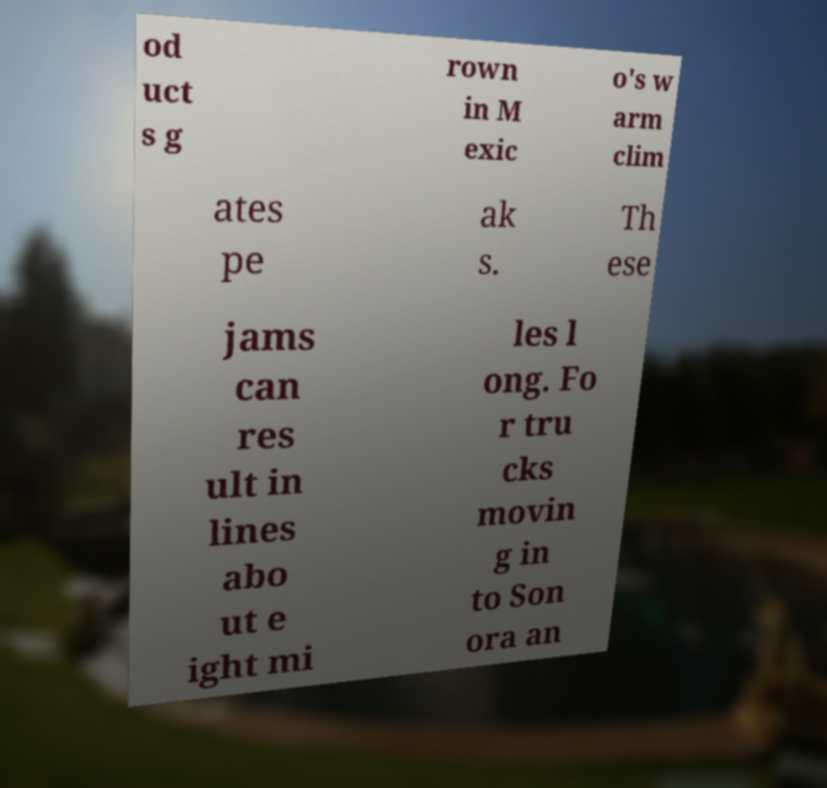There's text embedded in this image that I need extracted. Can you transcribe it verbatim? od uct s g rown in M exic o's w arm clim ates pe ak s. Th ese jams can res ult in lines abo ut e ight mi les l ong. Fo r tru cks movin g in to Son ora an 